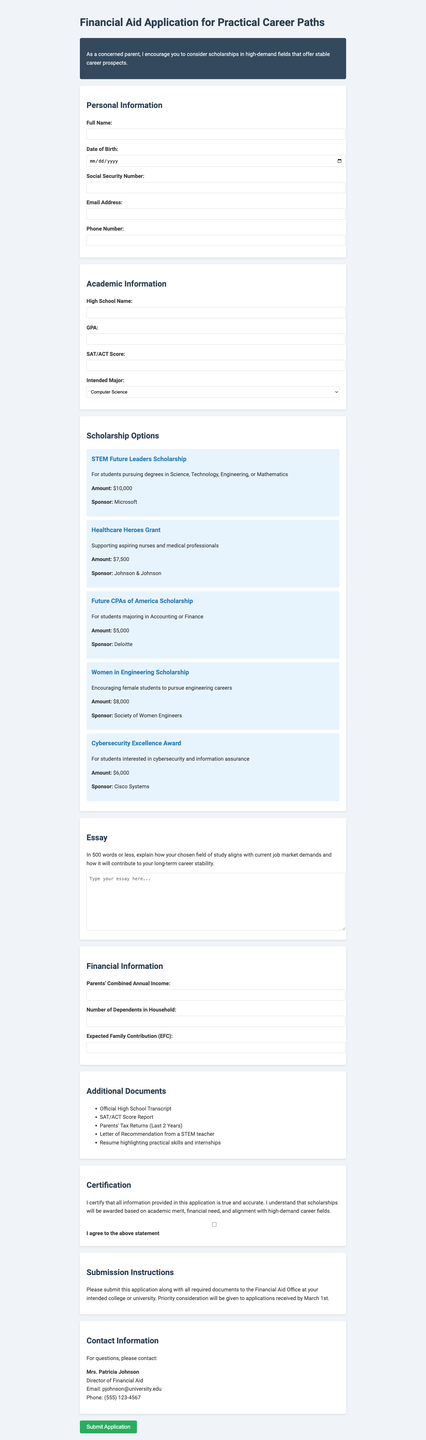what is the title of the form? The title of the form is stated at the top of the document.
Answer: Financial Aid Application for Practical Career Paths who is the sponsor of the Healthcare Heroes Grant? The document explicitly mentions the sponsor of the Healthcare Heroes Grant.
Answer: Johnson & Johnson what is the amount of the Cybersecurity Excellence Award? The award amount is listed alongside the scholarship description.
Answer: $6,000 what is the essay prompt? The essay prompt is provided in a specific section of the document.
Answer: In 500 words or less, explain how your chosen field of study aligns with current job market demands and how it will contribute to your long-term career stability how many dependents are in the household? The form asks for the number of dependents in the household as part of the financial information.
Answer: Number of Dependents in Household 